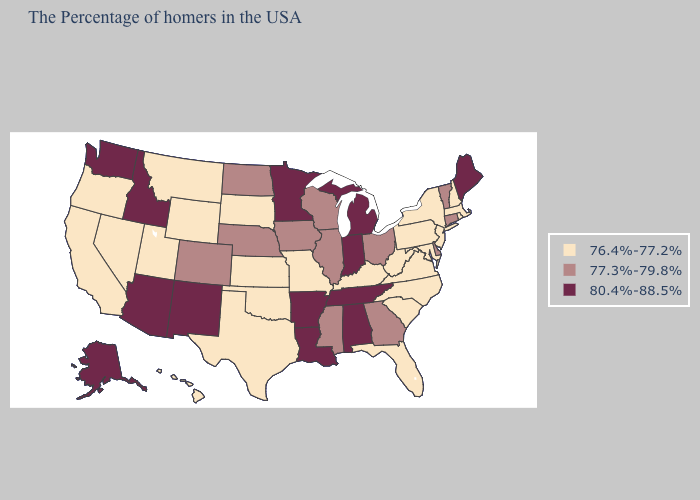Does the map have missing data?
Write a very short answer. No. Does Michigan have the highest value in the MidWest?
Concise answer only. Yes. Does the first symbol in the legend represent the smallest category?
Answer briefly. Yes. Which states have the highest value in the USA?
Keep it brief. Maine, Michigan, Indiana, Alabama, Tennessee, Louisiana, Arkansas, Minnesota, New Mexico, Arizona, Idaho, Washington, Alaska. What is the highest value in the USA?
Write a very short answer. 80.4%-88.5%. Does Washington have the same value as Arkansas?
Quick response, please. Yes. Does North Dakota have the lowest value in the MidWest?
Concise answer only. No. What is the lowest value in the South?
Write a very short answer. 76.4%-77.2%. What is the value of Michigan?
Quick response, please. 80.4%-88.5%. Does Vermont have the lowest value in the Northeast?
Quick response, please. No. Name the states that have a value in the range 77.3%-79.8%?
Quick response, please. Vermont, Connecticut, Delaware, Ohio, Georgia, Wisconsin, Illinois, Mississippi, Iowa, Nebraska, North Dakota, Colorado. What is the value of New Mexico?
Answer briefly. 80.4%-88.5%. Which states hav the highest value in the MidWest?
Answer briefly. Michigan, Indiana, Minnesota. What is the value of Tennessee?
Short answer required. 80.4%-88.5%. Name the states that have a value in the range 76.4%-77.2%?
Keep it brief. Massachusetts, Rhode Island, New Hampshire, New York, New Jersey, Maryland, Pennsylvania, Virginia, North Carolina, South Carolina, West Virginia, Florida, Kentucky, Missouri, Kansas, Oklahoma, Texas, South Dakota, Wyoming, Utah, Montana, Nevada, California, Oregon, Hawaii. 